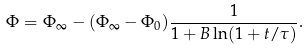Convert formula to latex. <formula><loc_0><loc_0><loc_500><loc_500>\Phi = \Phi _ { \infty } - ( \Phi _ { \infty } - \Phi _ { 0 } ) \frac { 1 } { 1 + B \ln ( { 1 + t } / { \tau } ) } .</formula> 